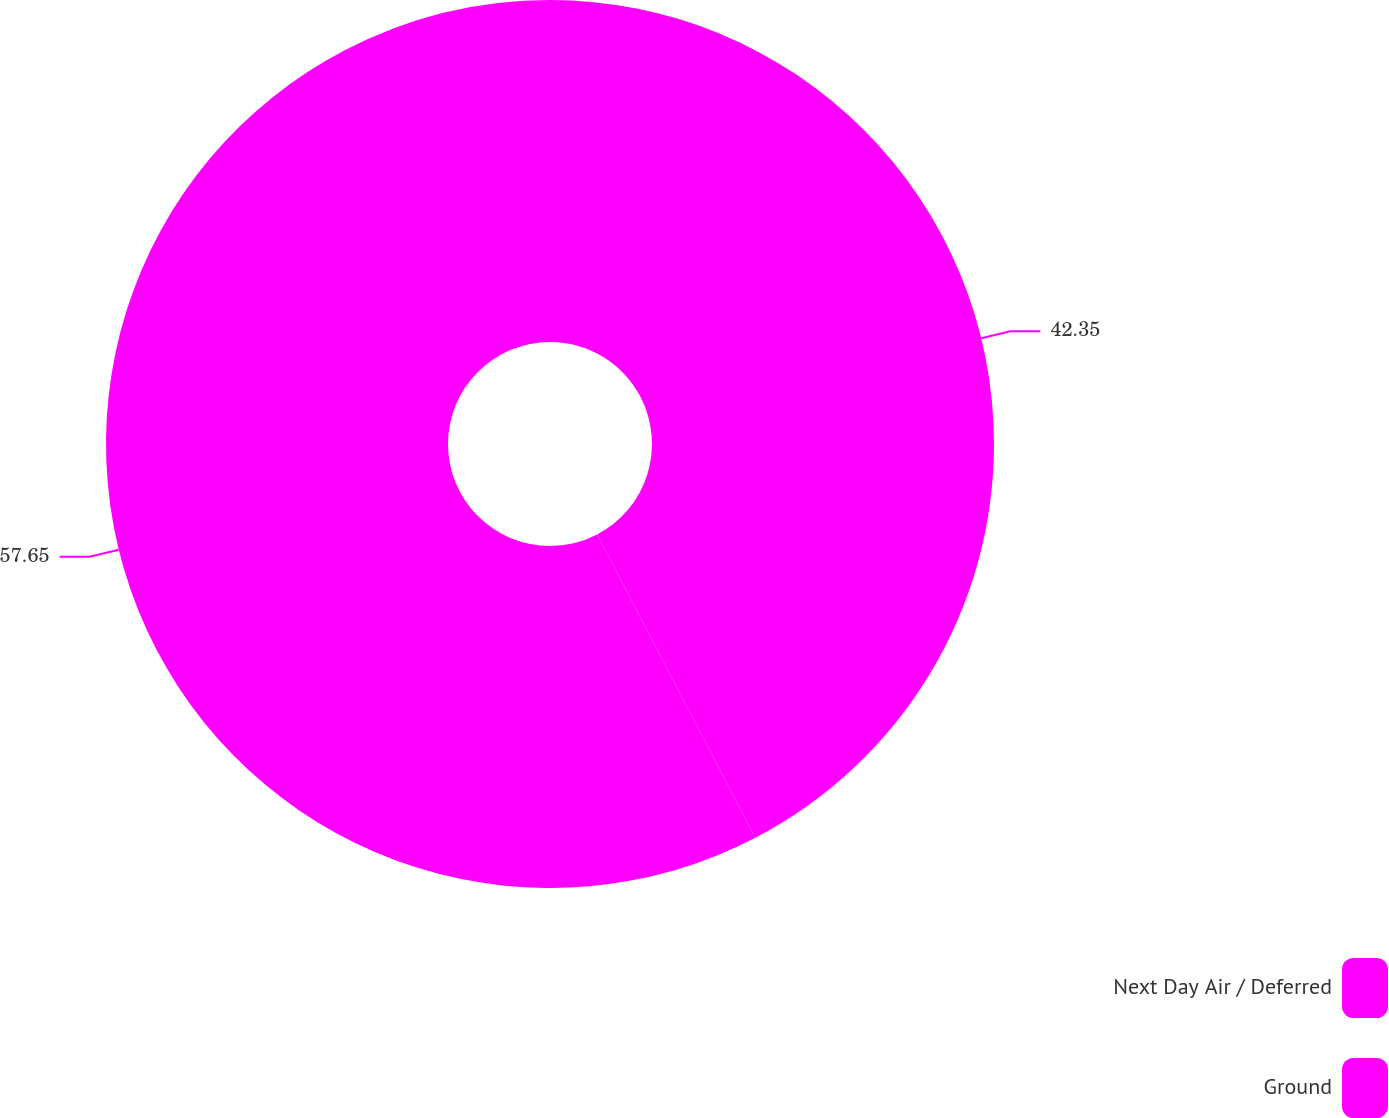Convert chart to OTSL. <chart><loc_0><loc_0><loc_500><loc_500><pie_chart><fcel>Next Day Air / Deferred<fcel>Ground<nl><fcel>42.35%<fcel>57.65%<nl></chart> 